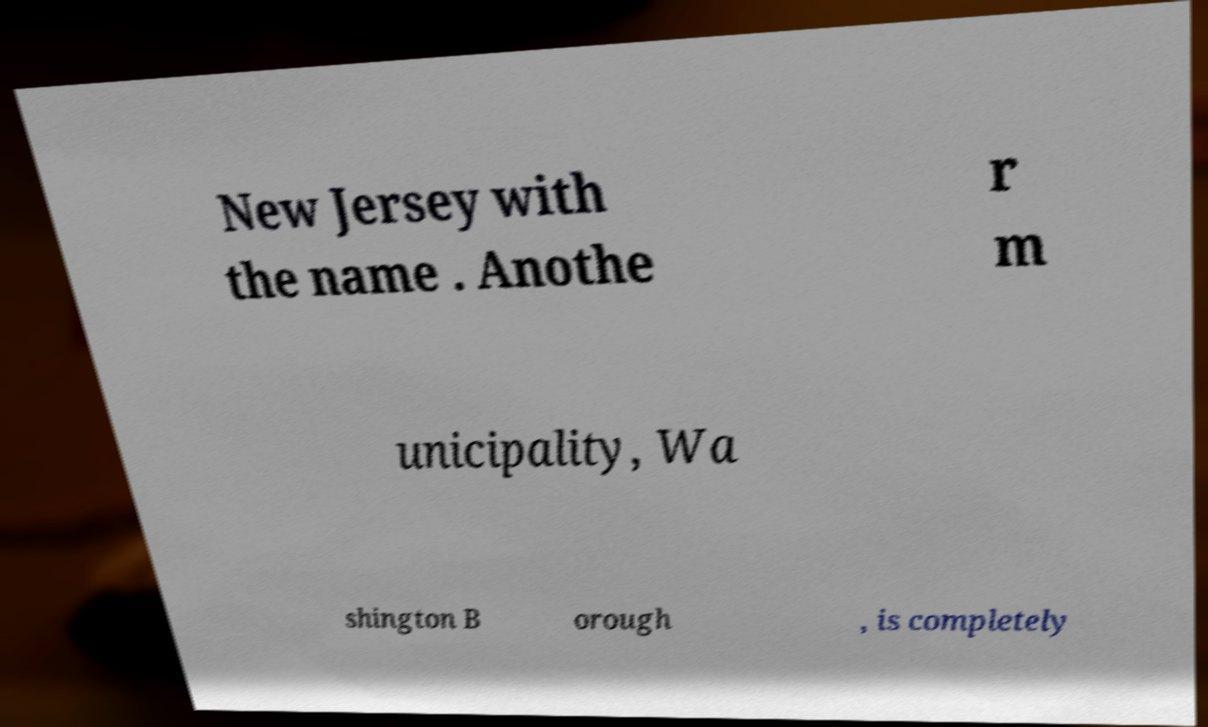Please read and relay the text visible in this image. What does it say? New Jersey with the name . Anothe r m unicipality, Wa shington B orough , is completely 